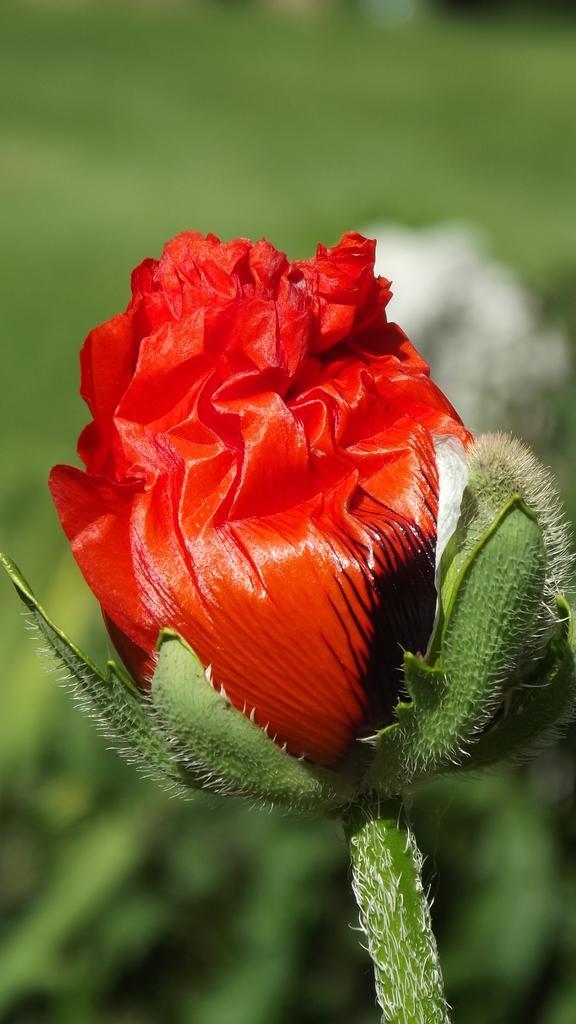Please provide a concise description of this image. In this image we can see a flower which is red in color and the background image is blur. 